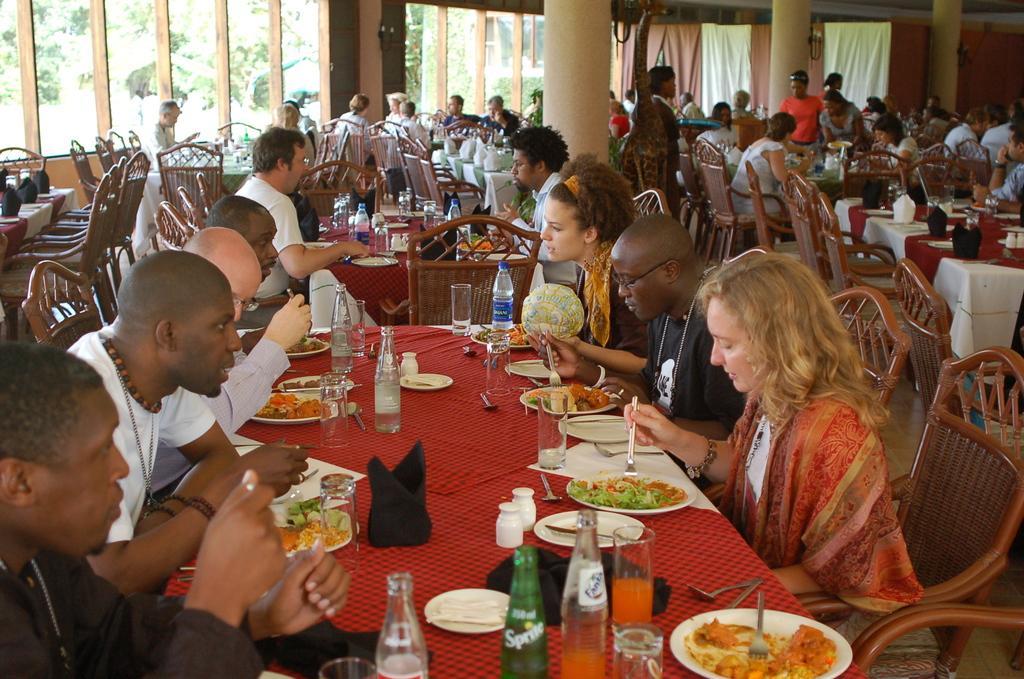Describe this image in one or two sentences. This image is clicked in a restaurant. There are Windows on the top side and through that Windows there are trees, there are so many chairs and tables. There are people sitting on chair around that tables. Tables has a red color cloth on it. On the tables there are water bottles, soft drinks, glasses, plates, knives, forks ,spoons ,eatables on that. There are curtains on the top right corner. There is napkin on the table. 